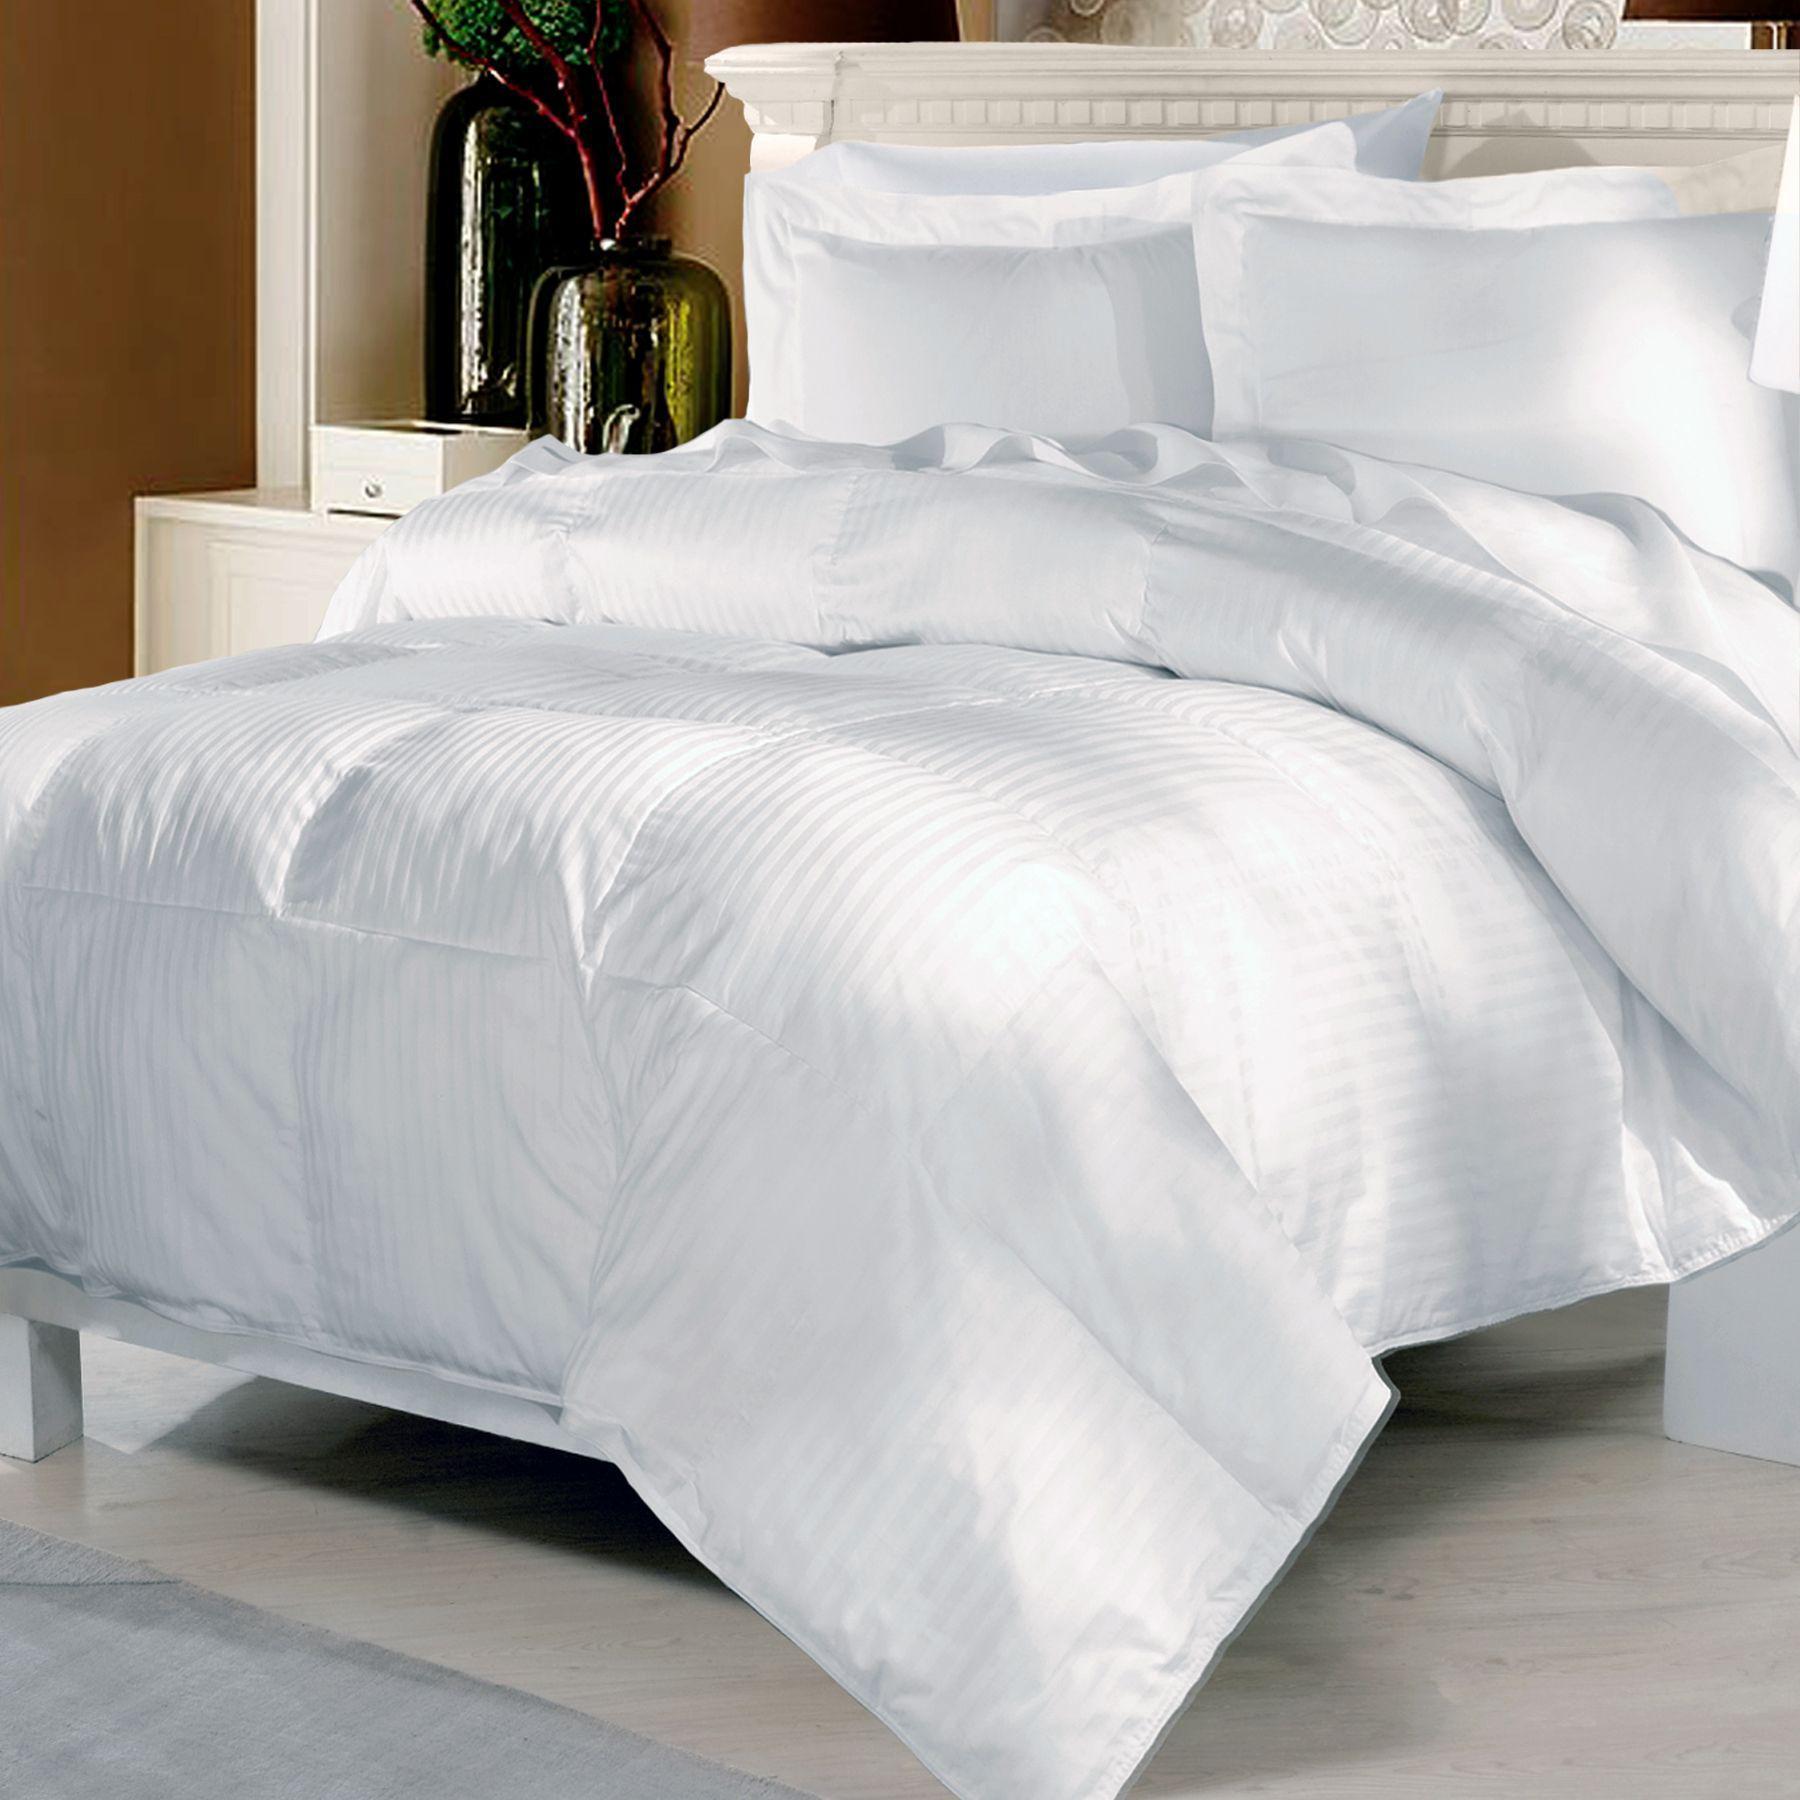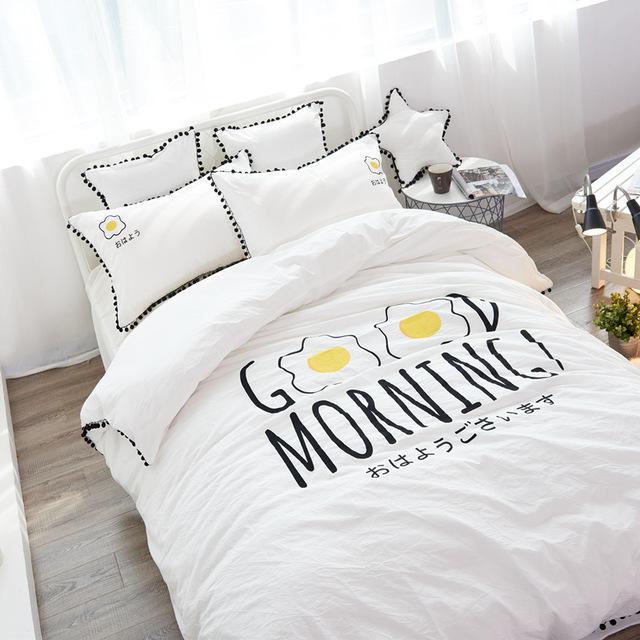The first image is the image on the left, the second image is the image on the right. For the images shown, is this caption "Pillows in both of the images have words written on them." true? Answer yes or no. No. The first image is the image on the left, the second image is the image on the right. Assess this claim about the two images: "The right image shows a bed with a white comforter and side-by-side white pillows printed with non-cursive dark letters, propped atop plain white pillows.". Correct or not? Answer yes or no. No. 